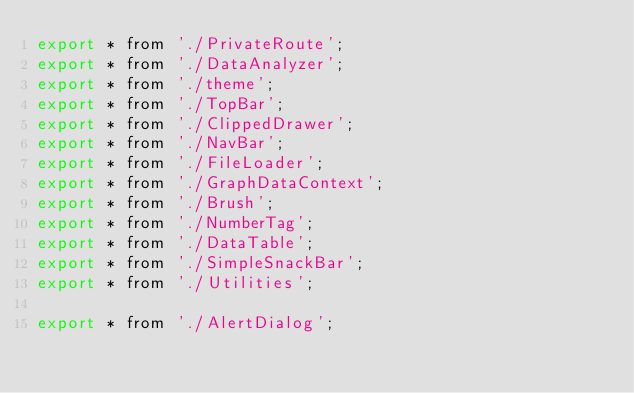Convert code to text. <code><loc_0><loc_0><loc_500><loc_500><_JavaScript_>export * from './PrivateRoute';
export * from './DataAnalyzer';
export * from './theme';
export * from './TopBar';
export * from './ClippedDrawer';
export * from './NavBar';
export * from './FileLoader';
export * from './GraphDataContext';
export * from './Brush';
export * from './NumberTag';
export * from './DataTable';
export * from './SimpleSnackBar';
export * from './Utilities';

export * from './AlertDialog';



</code> 